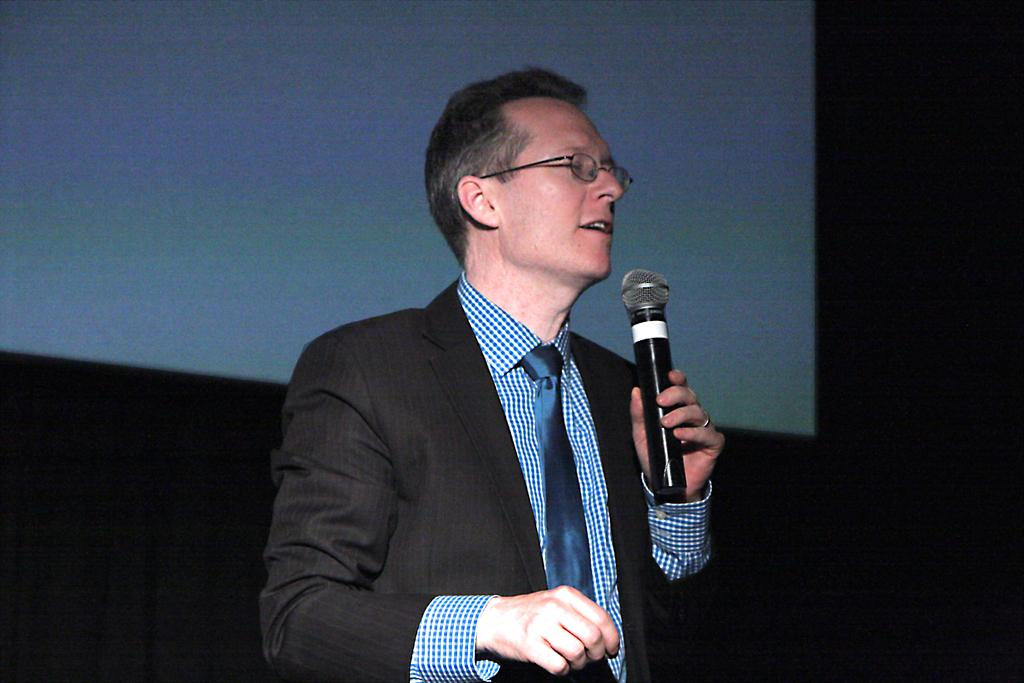Who is the main subject in the image? There is a man in the image. What is the man holding in the image? The man is holding a mic. Where is the faucet located in the image? There is no faucet present in the image. What type of education does the man in the image have? The provided facts do not mention the man's education, so we cannot determine that from the image. 